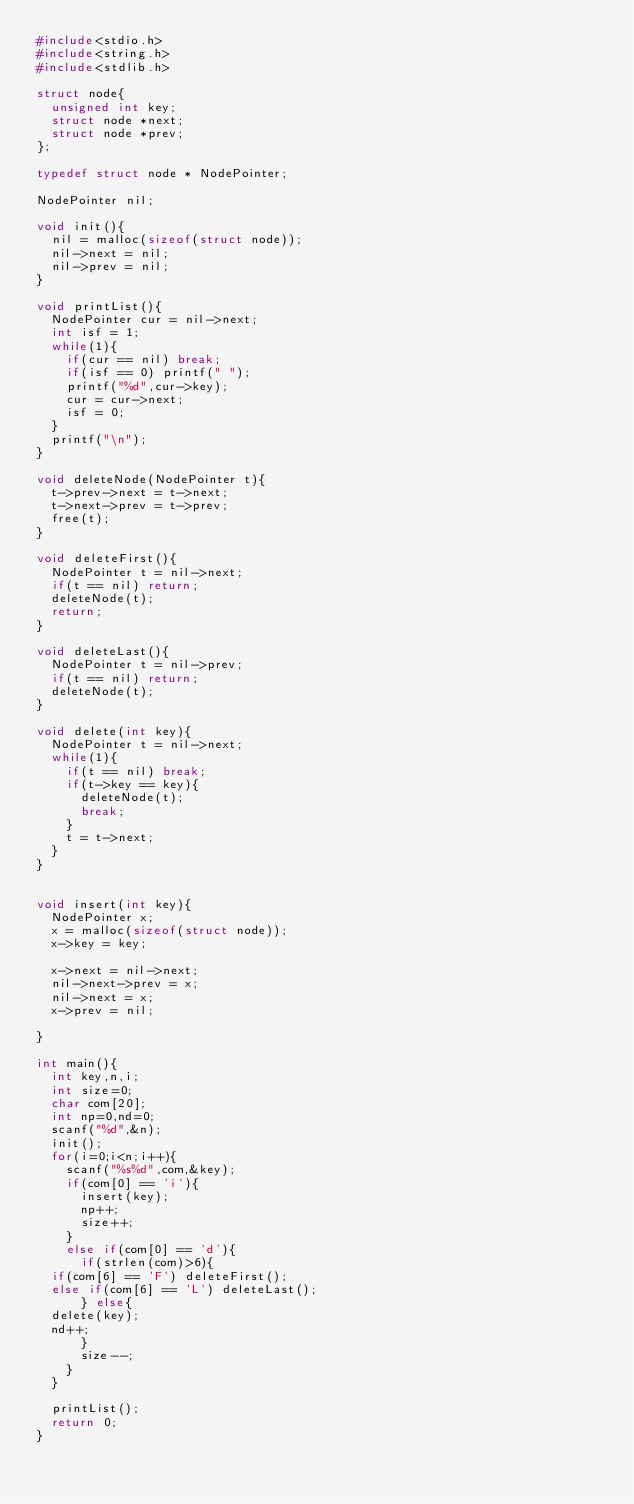<code> <loc_0><loc_0><loc_500><loc_500><_C_>#include<stdio.h>
#include<string.h>
#include<stdlib.h>

struct node{
  unsigned int key;
  struct node *next;
  struct node *prev;
};

typedef struct node * NodePointer;

NodePointer nil;

void init(){
  nil = malloc(sizeof(struct node));
  nil->next = nil;
  nil->prev = nil;
}

void printList(){
  NodePointer cur = nil->next;
  int isf = 1;
  while(1){
    if(cur == nil) break;
    if(isf == 0) printf(" ");
    printf("%d",cur->key);
    cur = cur->next;
    isf = 0;
  }
  printf("\n");
}

void deleteNode(NodePointer t){
  t->prev->next = t->next;
  t->next->prev = t->prev;
  free(t);
}

void deleteFirst(){
  NodePointer t = nil->next;
  if(t == nil) return;
  deleteNode(t);
  return;
}

void deleteLast(){
  NodePointer t = nil->prev;
  if(t == nil) return;
  deleteNode(t);
}

void delete(int key){
  NodePointer t = nil->next;
  while(1){
    if(t == nil) break;
    if(t->key == key){
      deleteNode(t);
      break;
    }
    t = t->next;
  }
}


void insert(int key){
  NodePointer x;
  x = malloc(sizeof(struct node));
  x->key = key;

  x->next = nil->next;
  nil->next->prev = x;
  nil->next = x;
  x->prev = nil;

}

int main(){
  int key,n,i;
  int size=0;
  char com[20];
  int np=0,nd=0;
  scanf("%d",&n);
  init();
  for(i=0;i<n;i++){
    scanf("%s%d",com,&key);
    if(com[0] == 'i'){
      insert(key);
      np++;
      size++;
    }
    else if(com[0] == 'd'){
      if(strlen(com)>6){
	if(com[6] == 'F') deleteFirst();
	else if(com[6] == 'L') deleteLast();
      } else{
	delete(key);
	nd++; 
      }
      size--;
    }
  }
  
  printList();
  return 0;
}

</code> 